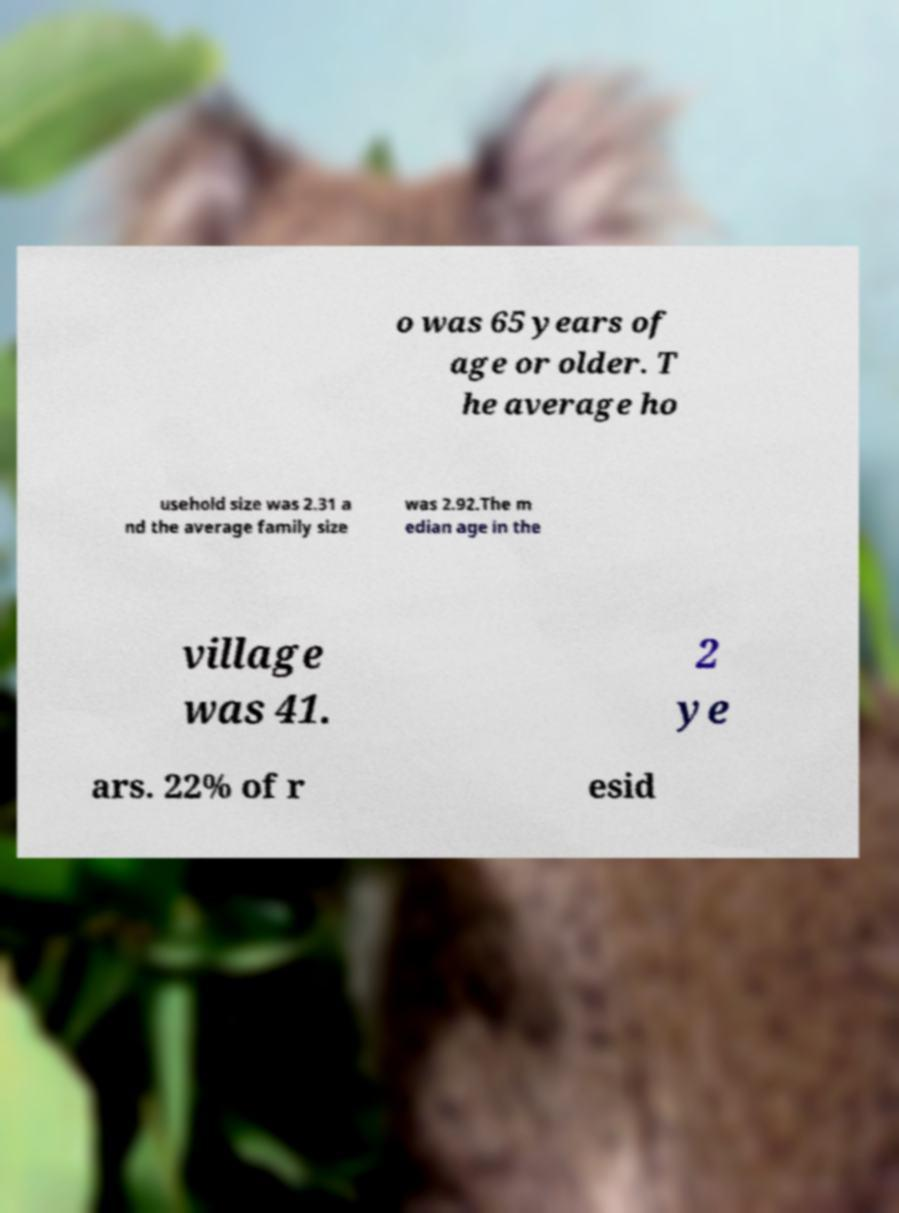Please identify and transcribe the text found in this image. o was 65 years of age or older. T he average ho usehold size was 2.31 a nd the average family size was 2.92.The m edian age in the village was 41. 2 ye ars. 22% of r esid 